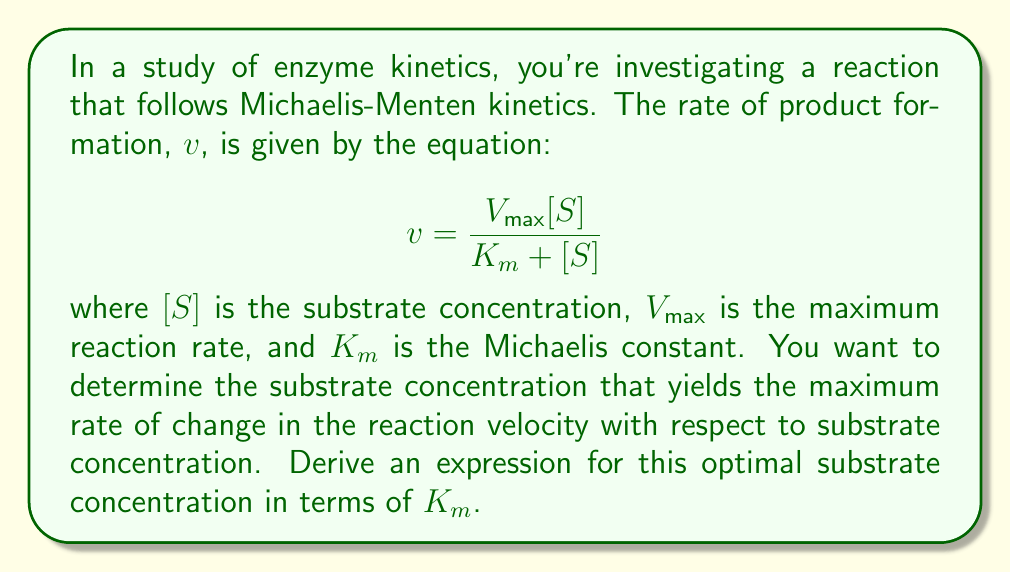What is the answer to this math problem? To solve this problem, we'll follow these steps:

1) First, we need to find the rate of change of velocity with respect to substrate concentration. This is given by the derivative $\frac{dv}{d[S]}$.

2) We can find this derivative using the quotient rule:

   $$\frac{dv}{d[S]} = \frac{(K_m + [S]) \cdot V_{max} - V_{max}[S] \cdot 1}{(K_m + [S])^2}$$

3) Simplifying this expression:

   $$\frac{dv}{d[S]} = \frac{V_{max}K_m}{(K_m + [S])^2}$$

4) To find the maximum of this function, we need to find where its derivative equals zero. However, the maximum of $\frac{dv}{d[S]}$ occurs at the same [S] as the maximum of its square. So, let's consider:

   $$f([S]) = \left(\frac{dv}{d[S]}\right)^2 = \frac{V_{max}^2K_m^2}{(K_m + [S])^4}$$

5) Now, let's find where the derivative of this function equals zero:

   $$\frac{df}{d[S]} = \frac{-4V_{max}^2K_m^2}{(K_m + [S])^5} = 0$$

6) This equation is satisfied when the numerator is zero, which never happens, or when the denominator is infinity, which also never happens. This means there's no local maximum.

7) However, we can find the point of inflection, which represents the substrate concentration where the rate of change is greatest. This occurs where the second derivative of $v$ with respect to [S] is zero.

8) The second derivative is:

   $$\frac{d^2v}{d[S]^2} = \frac{-2V_{max}K_m}{(K_m + [S])^3}$$

9) Setting this equal to zero:

   $$\frac{-2V_{max}K_m}{(K_m + [S])^3} = 0$$

10) This is true when $[S] = \infty$, which isn't helpful. However, the point of inflection occurs when this function changes most rapidly, which is at the substrate concentration that makes the denominator as small as possible while still being defined. This occurs when:

    $$[S] = K_m$$

Therefore, the substrate concentration that yields the maximum rate of change in the reaction velocity with respect to substrate concentration is equal to the Michaelis constant, $K_m$.
Answer: $[S] = K_m$ 